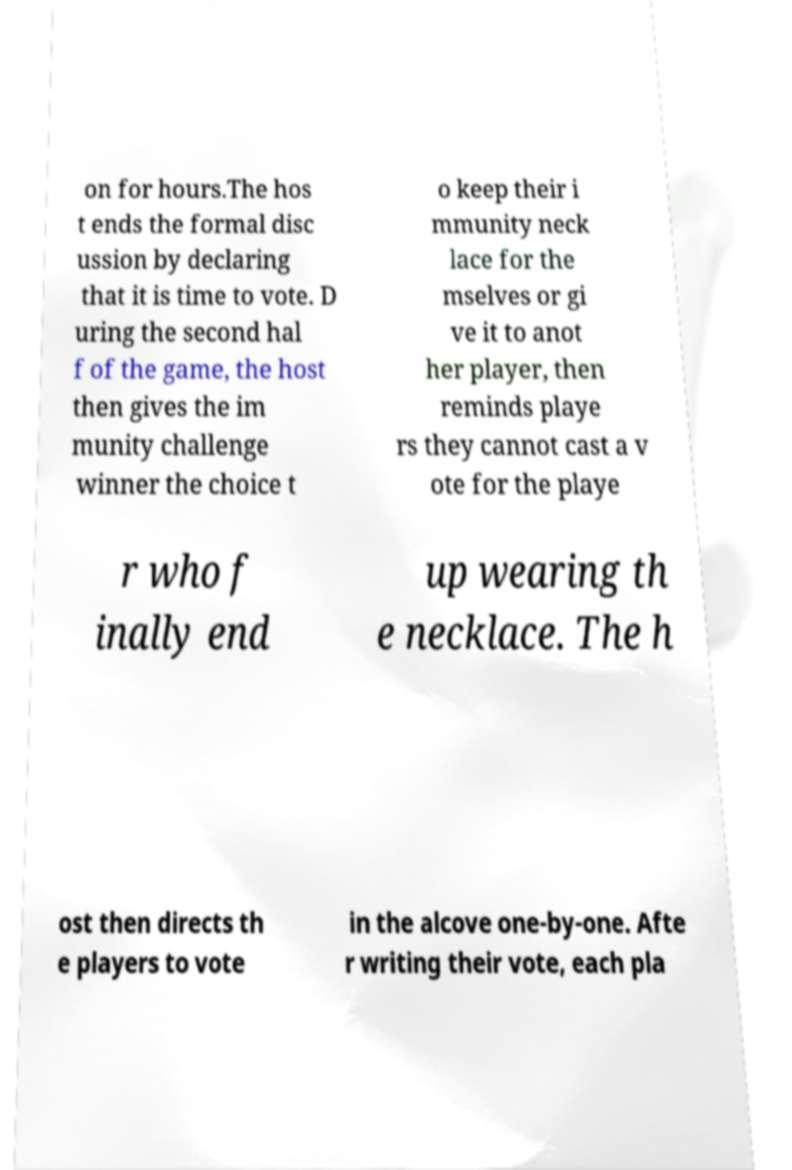Please read and relay the text visible in this image. What does it say? on for hours.The hos t ends the formal disc ussion by declaring that it is time to vote. D uring the second hal f of the game, the host then gives the im munity challenge winner the choice t o keep their i mmunity neck lace for the mselves or gi ve it to anot her player, then reminds playe rs they cannot cast a v ote for the playe r who f inally end up wearing th e necklace. The h ost then directs th e players to vote in the alcove one-by-one. Afte r writing their vote, each pla 